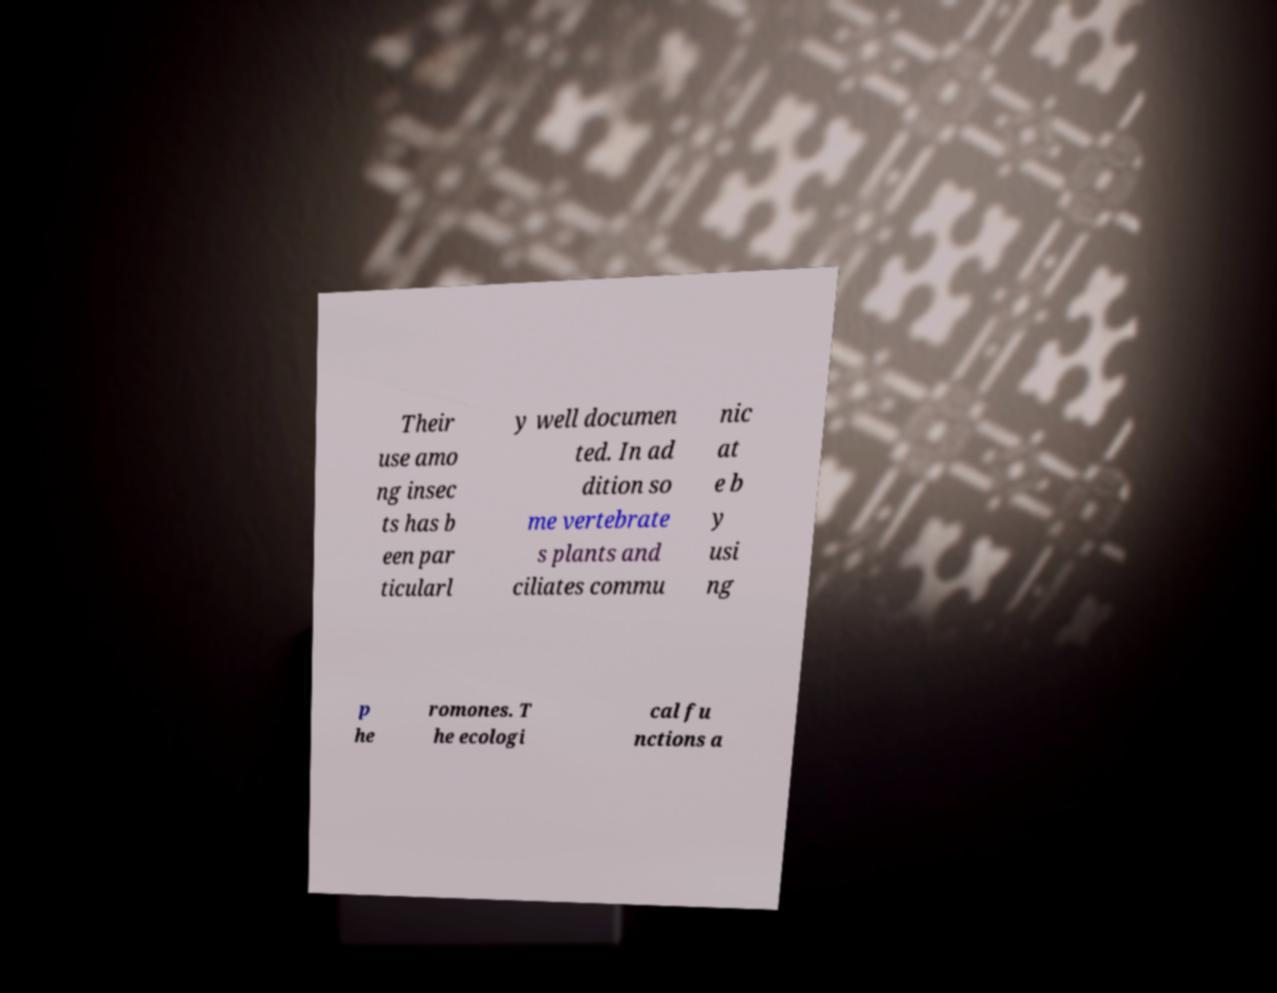For documentation purposes, I need the text within this image transcribed. Could you provide that? Their use amo ng insec ts has b een par ticularl y well documen ted. In ad dition so me vertebrate s plants and ciliates commu nic at e b y usi ng p he romones. T he ecologi cal fu nctions a 